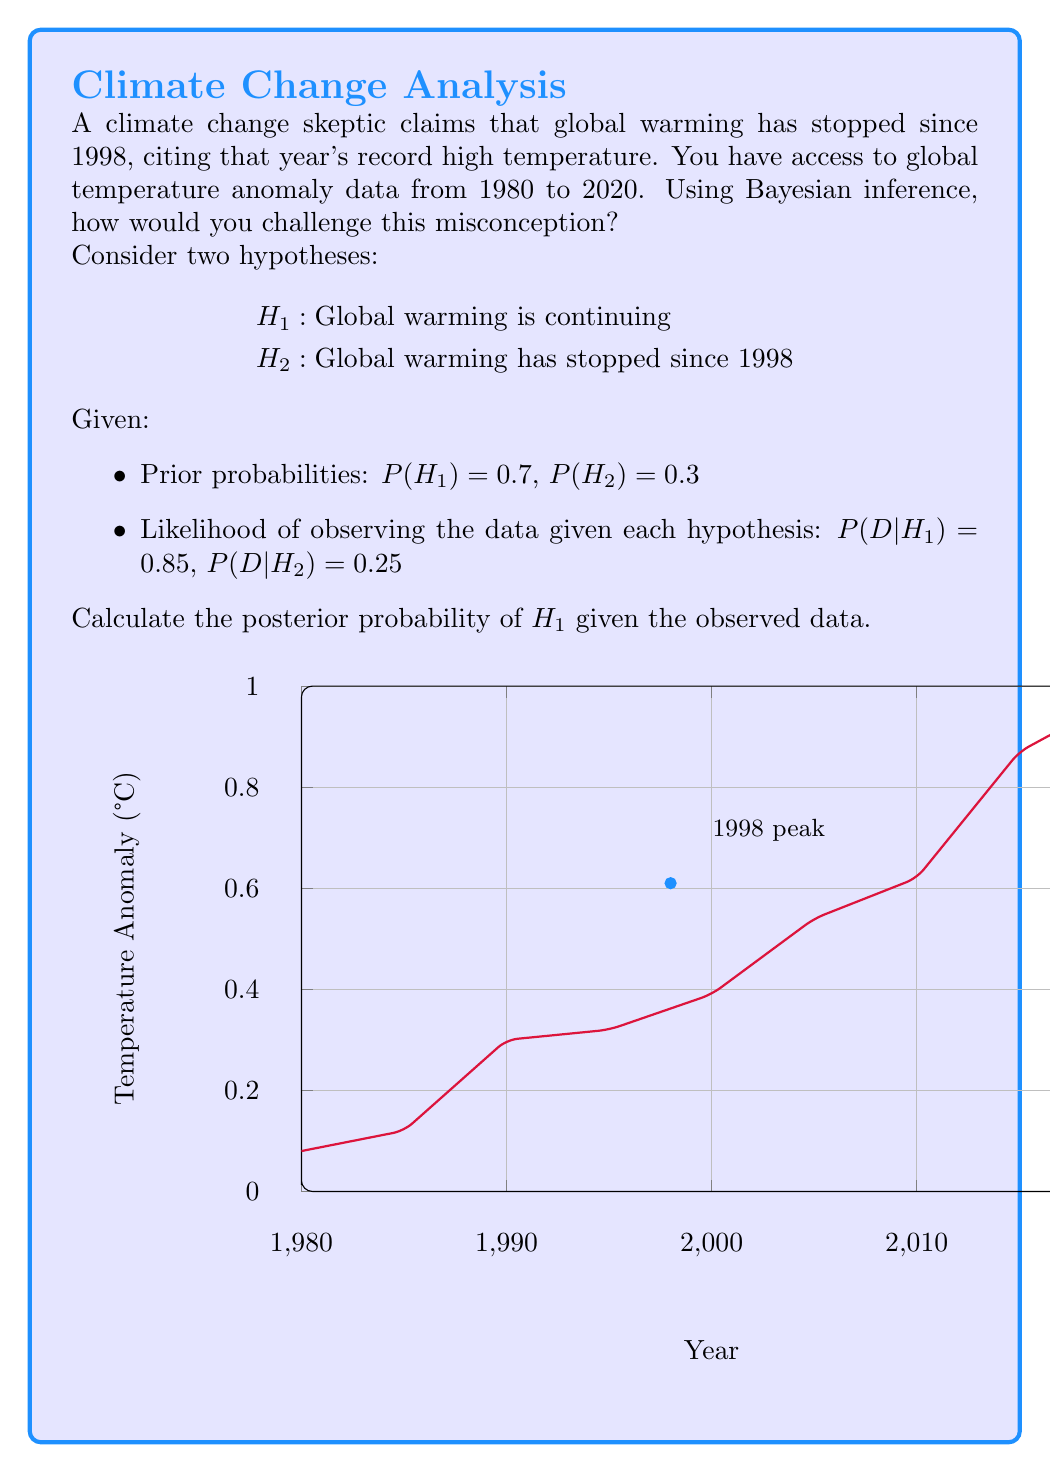Can you solve this math problem? To challenge the misconception using Bayesian inference, we'll calculate the posterior probability of $H_1$ (global warming is continuing) given the observed data. We'll use Bayes' theorem:

$$P(H_1|D) = \frac{P(D|H_1)P(H_1)}{P(D|H_1)P(H_1) + P(D|H_2)P(H_2)}$$

Step 1: Identify the given information
- Prior probability of $H_1$: $P(H_1) = 0.7$
- Prior probability of $H_2$: $P(H_2) = 0.3$
- Likelihood of data given $H_1$: $P(D|H_1) = 0.85$
- Likelihood of data given $H_2$: $P(D|H_2) = 0.25$

Step 2: Apply Bayes' theorem
$$P(H_1|D) = \frac{0.85 \times 0.7}{(0.85 \times 0.7) + (0.25 \times 0.3)}$$

Step 3: Calculate the numerator and denominator
Numerator: $0.85 \times 0.7 = 0.595$
Denominator: $(0.85 \times 0.7) + (0.25 \times 0.3) = 0.595 + 0.075 = 0.67$

Step 4: Divide the numerator by the denominator
$$P(H_1|D) = \frac{0.595}{0.67} \approx 0.8881$$

Step 5: Interpret the result
The posterior probability of $H_1$ (global warming is continuing) given the observed data is approximately 0.8881 or 88.81%. This high probability strongly supports the hypothesis that global warming is continuing, challenging the skeptic's claim.

To further reinforce this conclusion, we can point out that:
1. The graph shows an overall increasing trend in temperature anomalies from 1980 to 2020.
2. While 1998 was a peak year, subsequent years have shown higher temperature anomalies, particularly after 2010.
3. Focusing on a single year (1998) ignores the long-term trend and natural variability in the climate system.

By using Bayesian inference, we've quantitatively demonstrated that the evidence strongly supports the continuation of global warming, contrary to the skeptic's claim.
Answer: $P(H_1|D) \approx 0.8881$ or 88.81% 